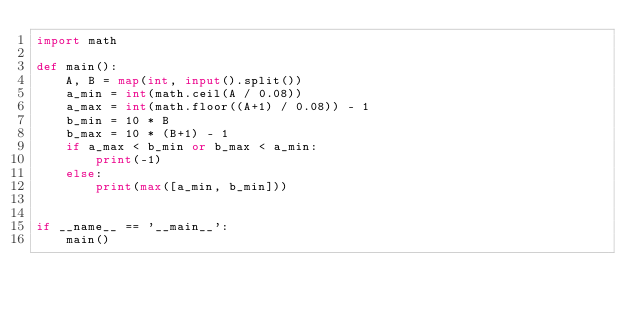Convert code to text. <code><loc_0><loc_0><loc_500><loc_500><_Python_>import math

def main():
    A, B = map(int, input().split())
    a_min = int(math.ceil(A / 0.08))
    a_max = int(math.floor((A+1) / 0.08)) - 1
    b_min = 10 * B
    b_max = 10 * (B+1) - 1
    if a_max < b_min or b_max < a_min:
        print(-1)
    else:
        print(max([a_min, b_min]))


if __name__ == '__main__':
    main()
</code> 